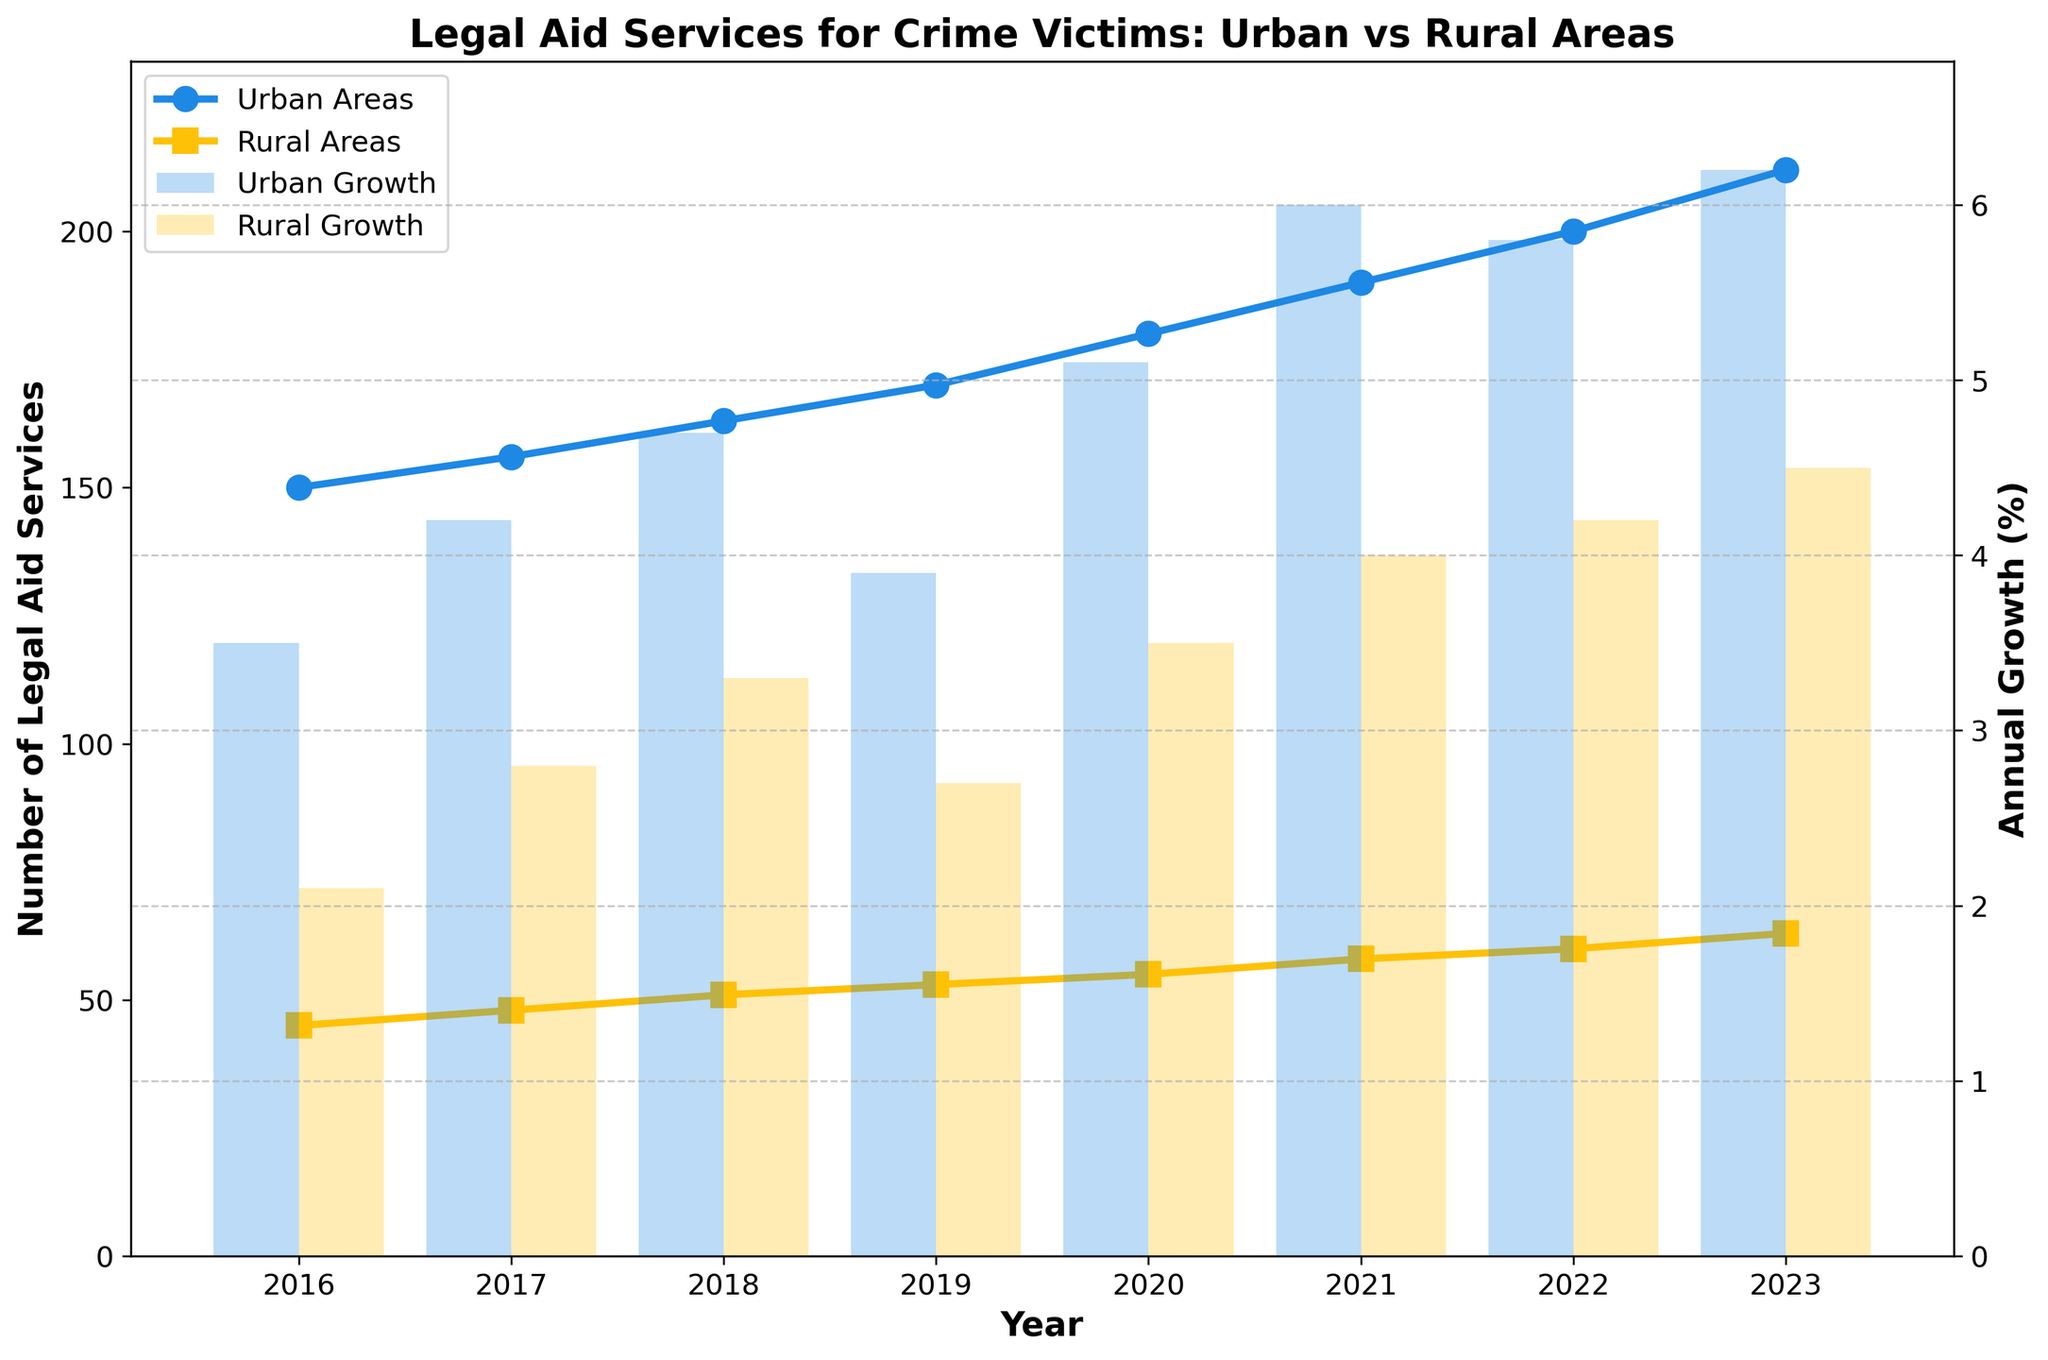What is the title of the figure? The title of the figure is typically placed at the top of a plot and summarizes the main focus of the data shown. In this case, it is clearly visible at the top.
Answer: "Legal Aid Services for Crime Victims: Urban vs Rural Areas" How many years of data are represented in the figure? To determine the number of years of data shown, you can count the distinct year data points plotted along the x-axis.
Answer: 8 Which area showed higher legal aid service numbers in 2023, urban or rural areas? To answer this, check the values at the year 2023 for both urban and rural areas from the plotted lines representing the number of services.
Answer: Urban areas What is the annual growth rate for urban areas in 2021? This information can be directly read from the bars representing the urban growth rate for the year 2021.
Answer: 6.0% What is the difference in the number of legal aid services between urban and rural areas in 2022? To find this, subtract the number of rural services from the number of urban services for the year 2022. Urban: 200, Rural: 60, Difference = 200 - 60.
Answer: 140 Which year had the highest annual growth rate for rural areas? Look at the height of the bars representing the rural growth rate across all years and identify the tallest bar.
Answer: 2023 How does the number of services in urban areas compare to rural areas over the years? Observe the trends in the line plots over the years for both urban and rural areas. Urban areas consistently have higher service numbers.
Answer: Urban areas have higher services each year What is the average annual growth rate for rural areas over the given period? Sum the annual growth rates for rural areas and divide by the number of years. (2.1 + 2.8 + 3.3 + 2.7 + 3.5 + 4.0 + 4.2 + 4.5) / 8 = 27.1 / 8.
Answer: 3.39% In which year did urban areas experience a growth higher than 5%? Examine the bar plot for urban growth rates and identify the years where the bar exceeds 5%.
Answer: 2020, 2021, 2022, 2023 What is the trend of legal aid services in rural areas from 2016 to 2023? Look at the line representing rural services from 2016 to 2023 and observe if it generally increases, decreases, or remains constant.
Answer: Increasing 